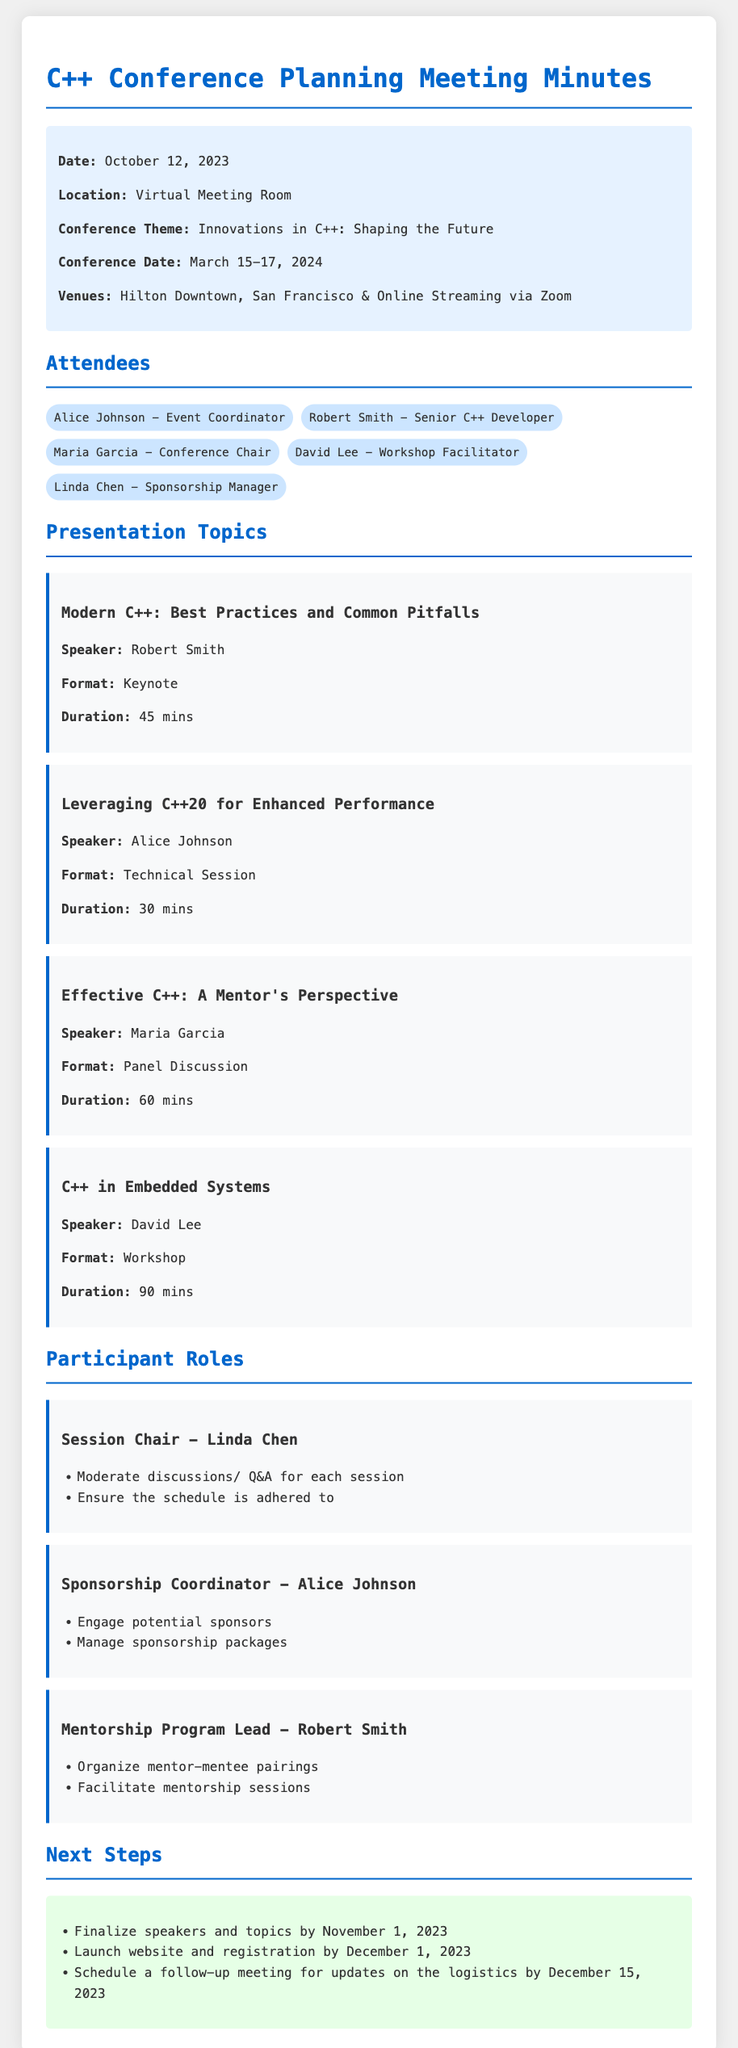What is the date of the conference? The conference date is specifically mentioned in the document as March 15-17, 2024.
Answer: March 15-17, 2024 Who is the speaker for the keynote session? The speaker for the keynote session, “Modern C++: Best Practices and Common Pitfalls,” is listed in the document as Robert Smith.
Answer: Robert Smith What role does Linda Chen have in the conference? The document specifies that Linda Chen is the Session Chair, along with her responsibilities outlined.
Answer: Session Chair How long is the workshop on C++ in Embedded Systems? The document states that the duration of this workshop is 90 minutes.
Answer: 90 mins What is the theme of the conference? The theme of the conference is explicitly stated as "Innovations in C++: Shaping the Future."
Answer: Innovations in C++: Shaping the Future What is the next step due date for finalizing speakers? According to the document, speakers need to be finalized by November 1, 2023.
Answer: November 1, 2023 What format is “Effective C++: A Mentor's Perspective”? The document categorizes this presentation as a Panel Discussion under the format section.
Answer: Panel Discussion Which venue will also stream online? The document indicates that the Hilton Downtown, San Francisco will also host an online streaming option via Zoom.
Answer: Online Streaming via Zoom 